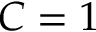Convert formula to latex. <formula><loc_0><loc_0><loc_500><loc_500>C = 1</formula> 